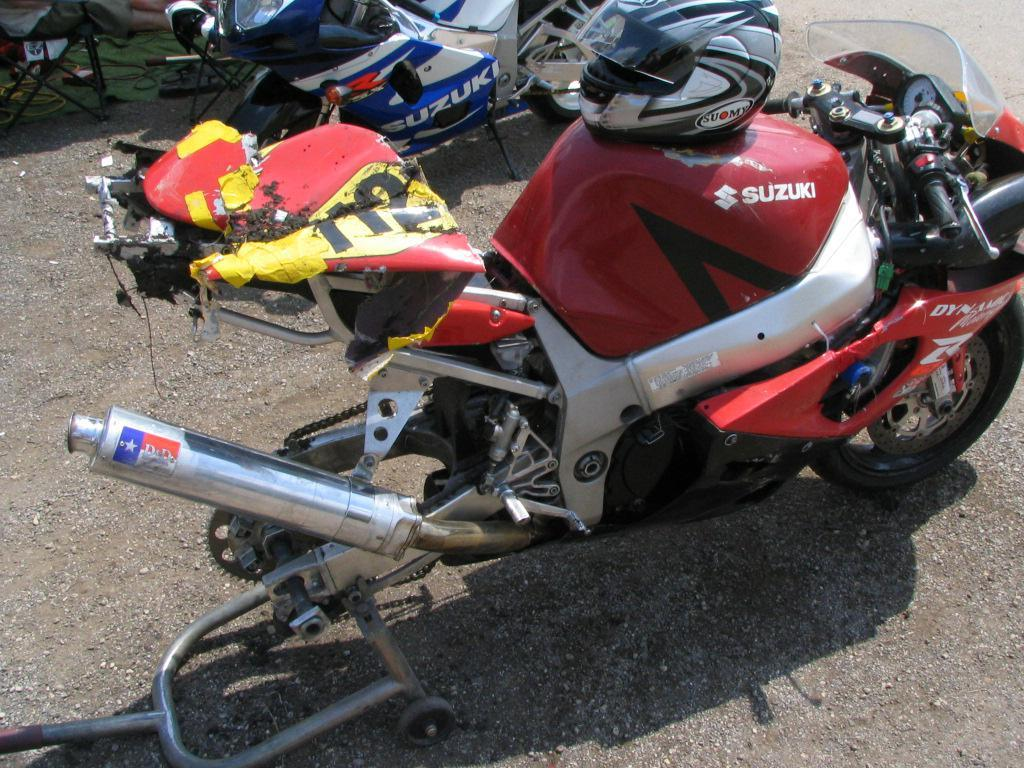What type of vehicles are on the road in the image? There are motorbikes on the road in the image. What safety equipment is visible in the image? There are helmets visible in the image. What type of furniture can be seen in the background of the image? There are chairs in the background of the image. What type of rock is being used as a seat for the motorbikes in the image? There is no rock being used as a seat for the motorbikes in the image; the chairs are in the background. 